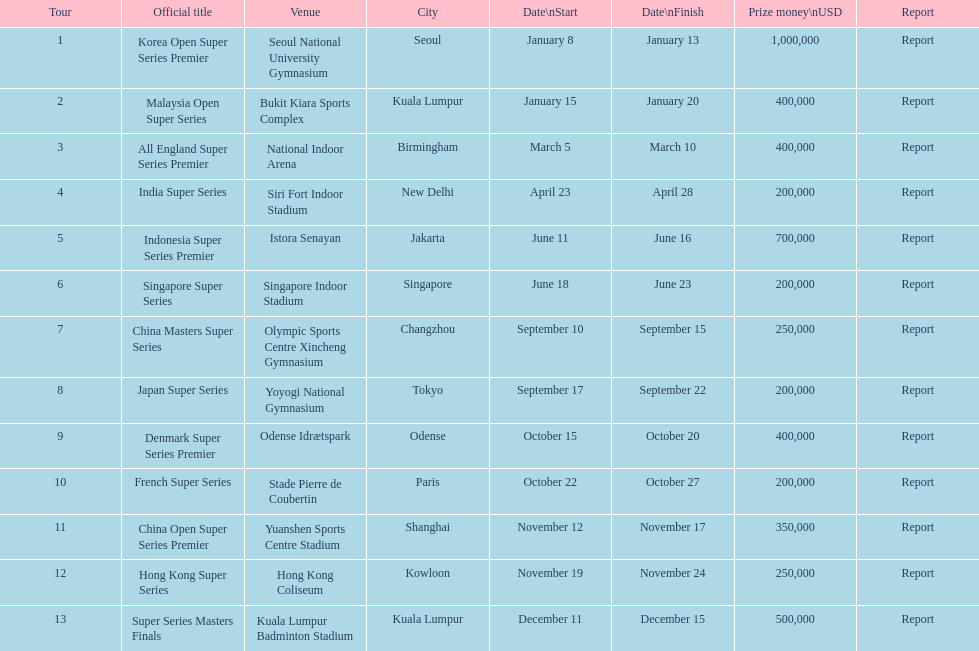What is the combined prize money for all 13 series? 5050000. 